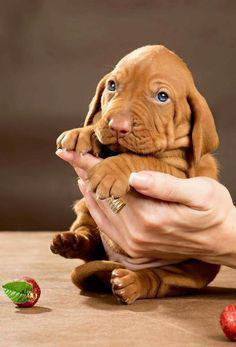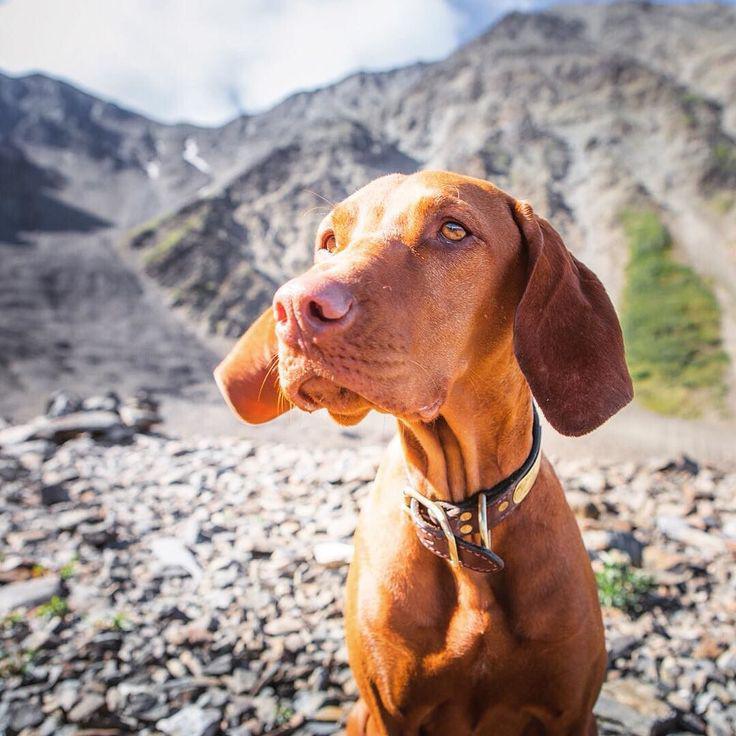The first image is the image on the left, the second image is the image on the right. Examine the images to the left and right. Is the description "A dog is laying down inside." accurate? Answer yes or no. No. The first image is the image on the left, the second image is the image on the right. For the images shown, is this caption "The left image features a puppy peering over a wooden ledge, and the right image includes a reclining adult dog with its head lifted to gaze upward." true? Answer yes or no. No. 